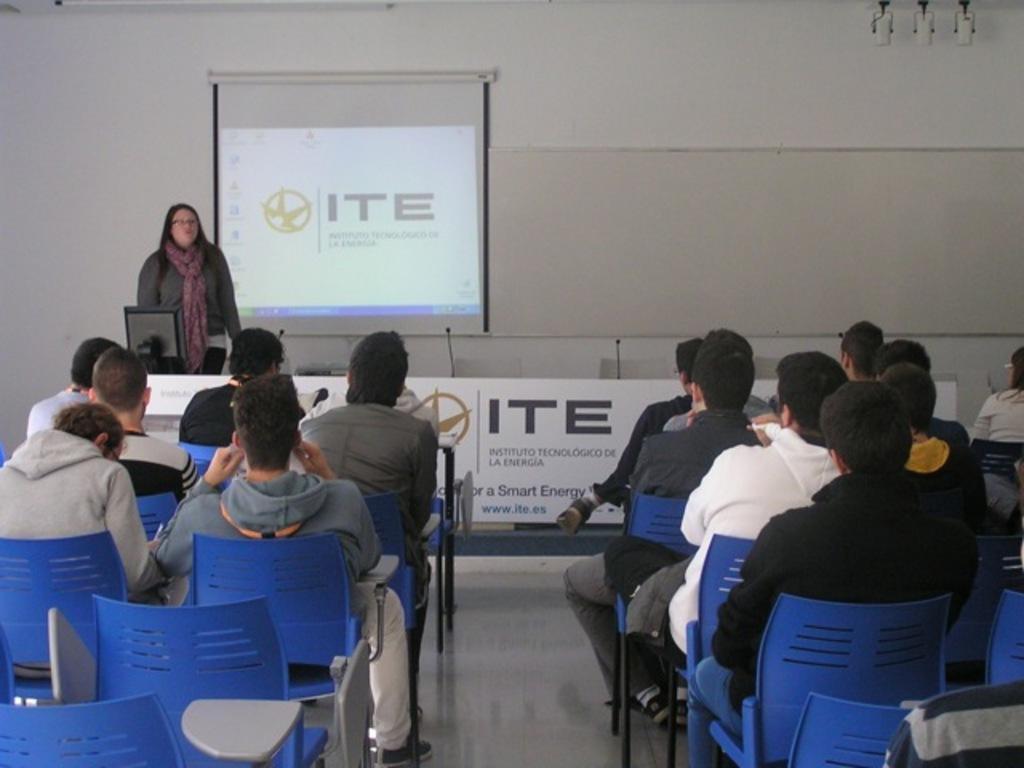How would you summarize this image in a sentence or two? In this image I can see few people are sitting on the chairs. I can see few mics, monitor, board and one person is standing. I can see the projection screen and the board is attached to the wall. 